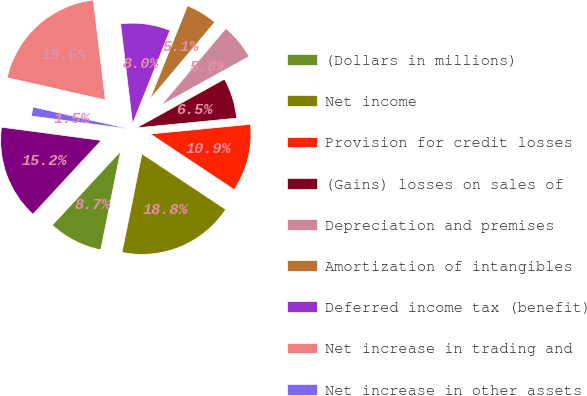Convert chart to OTSL. <chart><loc_0><loc_0><loc_500><loc_500><pie_chart><fcel>(Dollars in millions)<fcel>Net income<fcel>Provision for credit losses<fcel>(Gains) losses on sales of<fcel>Depreciation and premises<fcel>Amortization of intangibles<fcel>Deferred income tax (benefit)<fcel>Net increase in trading and<fcel>Net increase in other assets<fcel>Net increase (decrease) in<nl><fcel>8.7%<fcel>18.84%<fcel>10.87%<fcel>6.52%<fcel>5.8%<fcel>5.07%<fcel>7.97%<fcel>19.56%<fcel>1.45%<fcel>15.22%<nl></chart> 